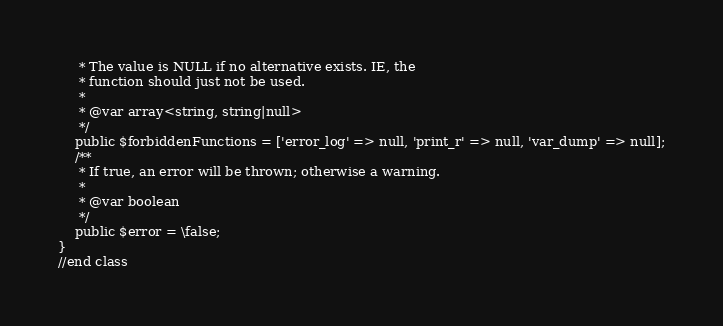<code> <loc_0><loc_0><loc_500><loc_500><_PHP_>     * The value is NULL if no alternative exists. IE, the
     * function should just not be used.
     *
     * @var array<string, string|null>
     */
    public $forbiddenFunctions = ['error_log' => null, 'print_r' => null, 'var_dump' => null];
    /**
     * If true, an error will be thrown; otherwise a warning.
     *
     * @var boolean
     */
    public $error = \false;
}
//end class
</code> 